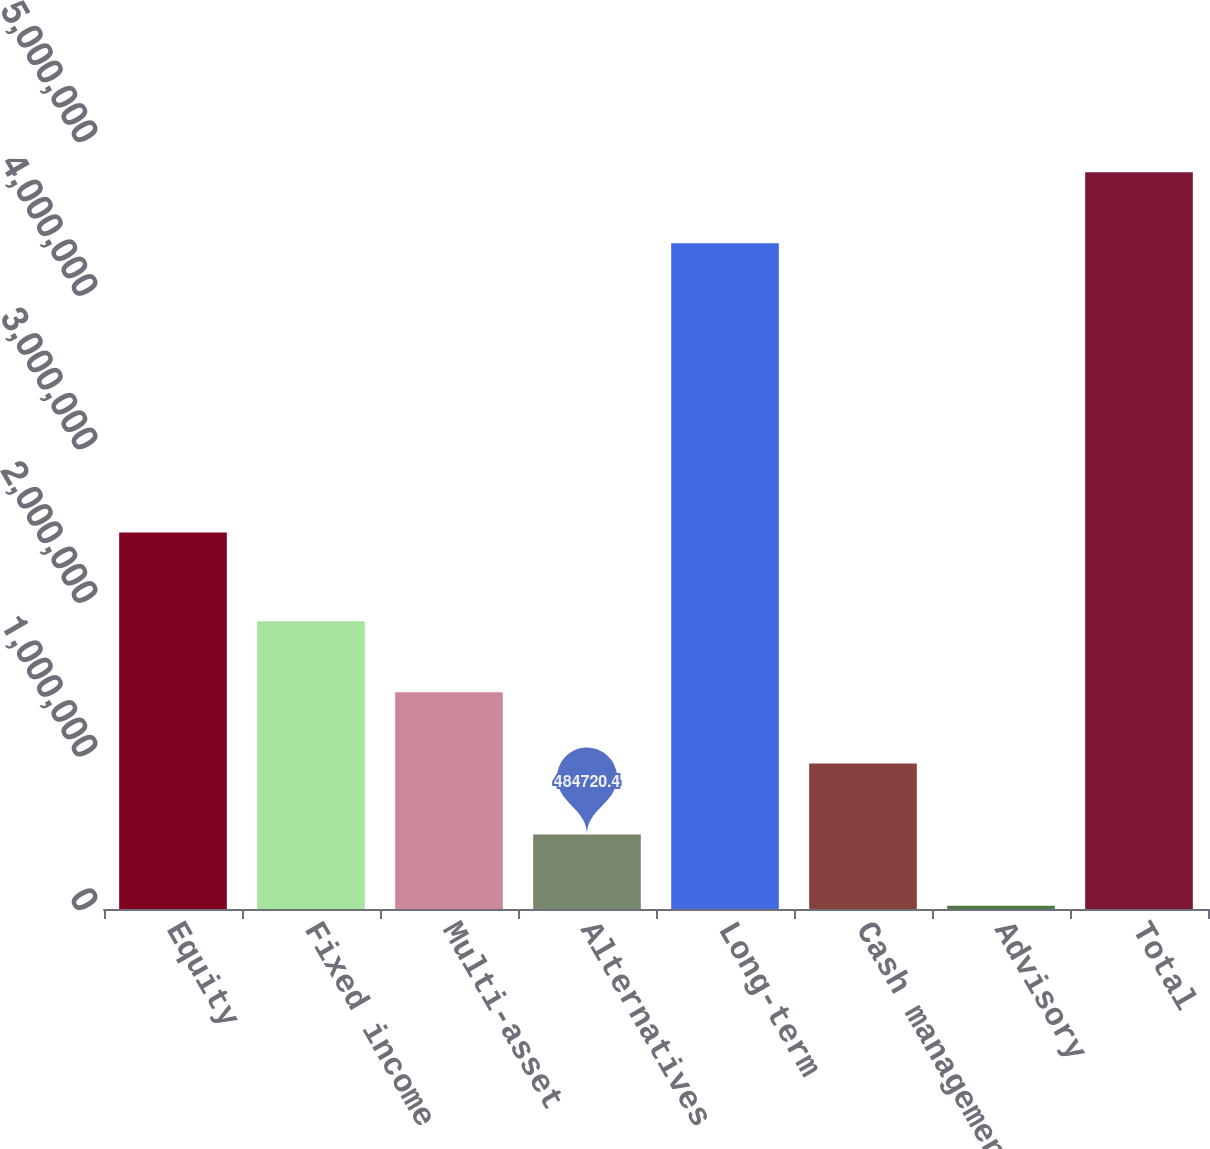<chart> <loc_0><loc_0><loc_500><loc_500><bar_chart><fcel>Equity<fcel>Fixed income<fcel>Multi-asset<fcel>Alternatives<fcel>Long-term<fcel>Cash management<fcel>Advisory<fcel>Total<nl><fcel>2.45111e+06<fcel>1.87378e+06<fcel>1.41076e+06<fcel>484720<fcel>4.33384e+06<fcel>947740<fcel>21701<fcel>4.79686e+06<nl></chart> 